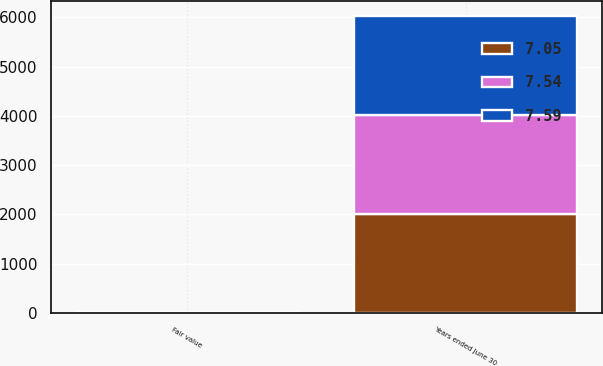Convert chart to OTSL. <chart><loc_0><loc_0><loc_500><loc_500><stacked_bar_chart><ecel><fcel>Years ended June 30<fcel>Fair value<nl><fcel>7.59<fcel>2011<fcel>7.59<nl><fcel>7.05<fcel>2010<fcel>7.05<nl><fcel>7.54<fcel>2009<fcel>7.54<nl></chart> 